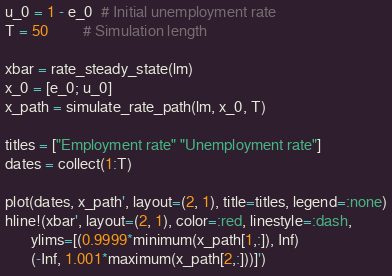Convert code to text. <code><loc_0><loc_0><loc_500><loc_500><_Julia_>u_0 = 1 - e_0  # Initial unemployment rate
T = 50         # Simulation length

xbar = rate_steady_state(lm)
x_0 = [e_0; u_0]
x_path = simulate_rate_path(lm, x_0, T)

titles = ["Employment rate" "Unemployment rate"]
dates = collect(1:T)

plot(dates, x_path', layout=(2, 1), title=titles, legend=:none)
hline!(xbar', layout=(2, 1), color=:red, linestyle=:dash,
       ylims=[(0.9999*minimum(x_path[1,:]), Inf)
       (-Inf, 1.001*maximum(x_path[2,:]))]')
</code> 